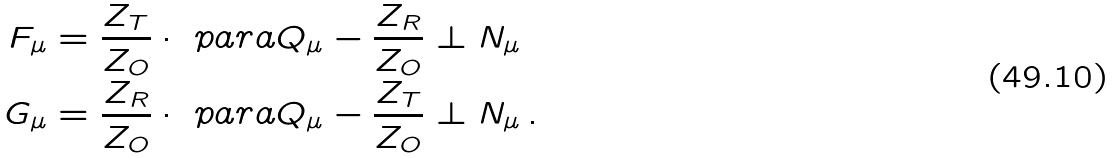Convert formula to latex. <formula><loc_0><loc_0><loc_500><loc_500>F _ { \mu } & = \frac { Z _ { T } } { Z _ { O } } \cdot \ p a r a Q _ { \mu } - \frac { Z _ { R } } { Z _ { O } } \perp N _ { \mu } \\ G _ { \mu } & = \frac { Z _ { R } } { Z _ { O } } \cdot \ p a r a Q _ { \mu } - \frac { Z _ { T } } { Z _ { O } } \perp N _ { \mu } \, .</formula> 